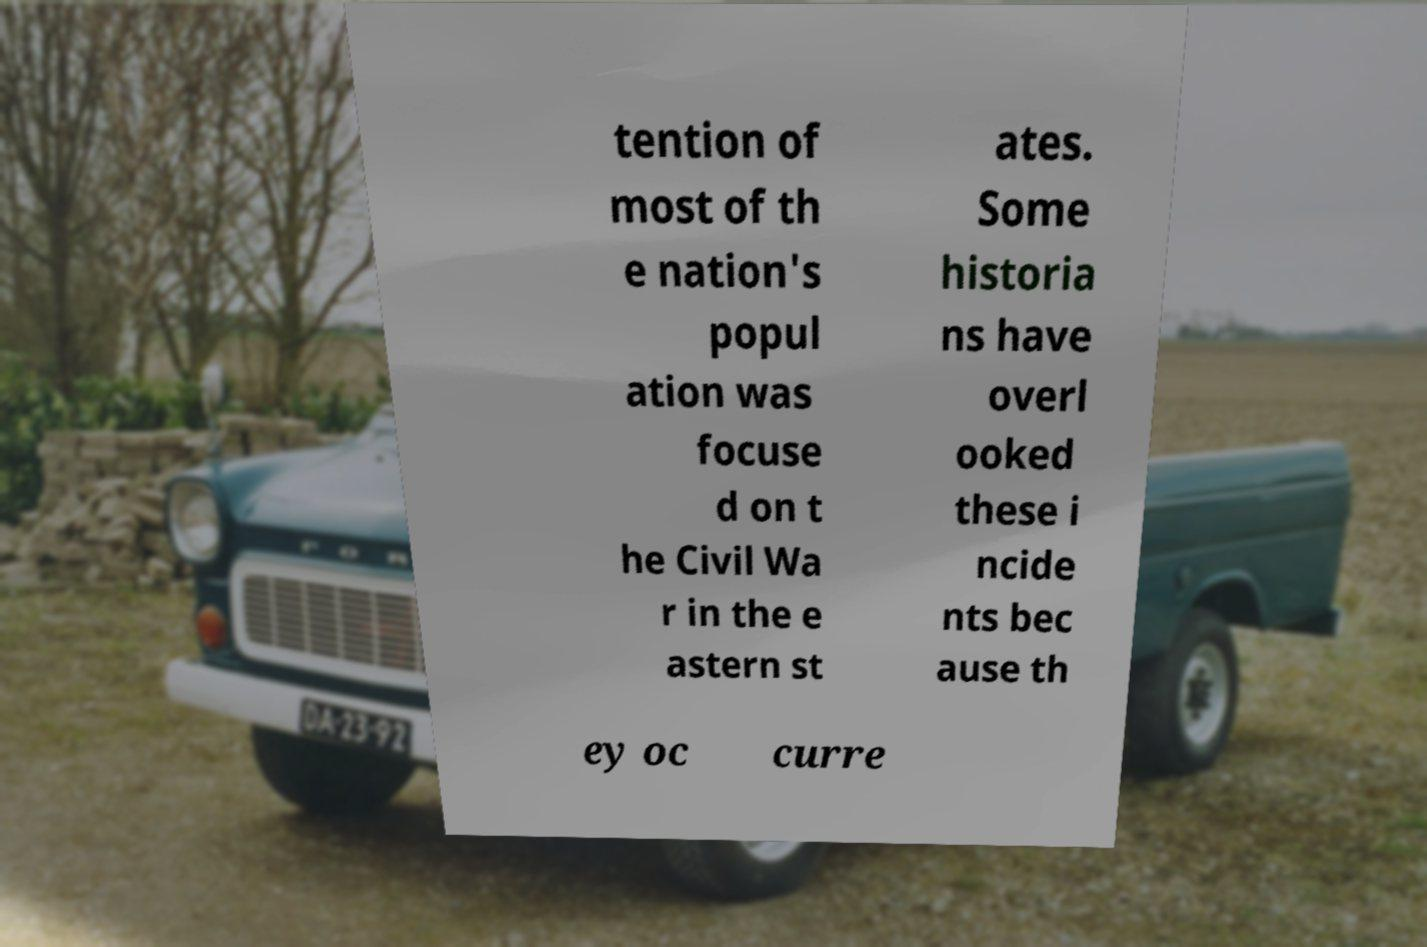Could you extract and type out the text from this image? tention of most of th e nation's popul ation was focuse d on t he Civil Wa r in the e astern st ates. Some historia ns have overl ooked these i ncide nts bec ause th ey oc curre 